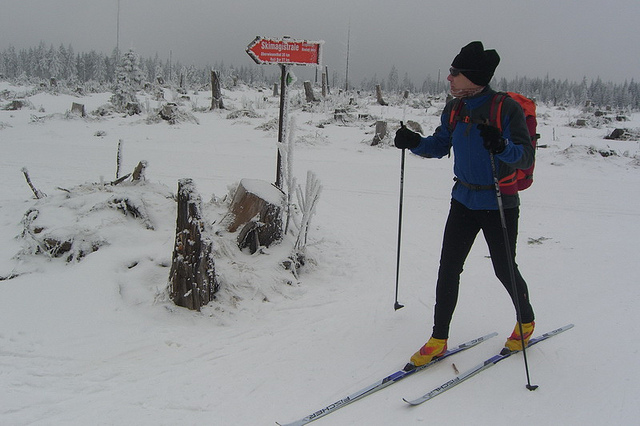<image>What mountain was this taken at? It is unknown what mountain was this taken at. It can be Rushmore, Sky Magistrate, Sugar Mountain, Skimapalrnie or Smokey Mountain. What mountain was this taken at? I don't know at which mountain this picture was taken. The options are 'rushmore', 'sky magistrate', 'sugar mountain', 'skimapalrnie', 'snowy one', 'skina', 'smokey mountain'. 